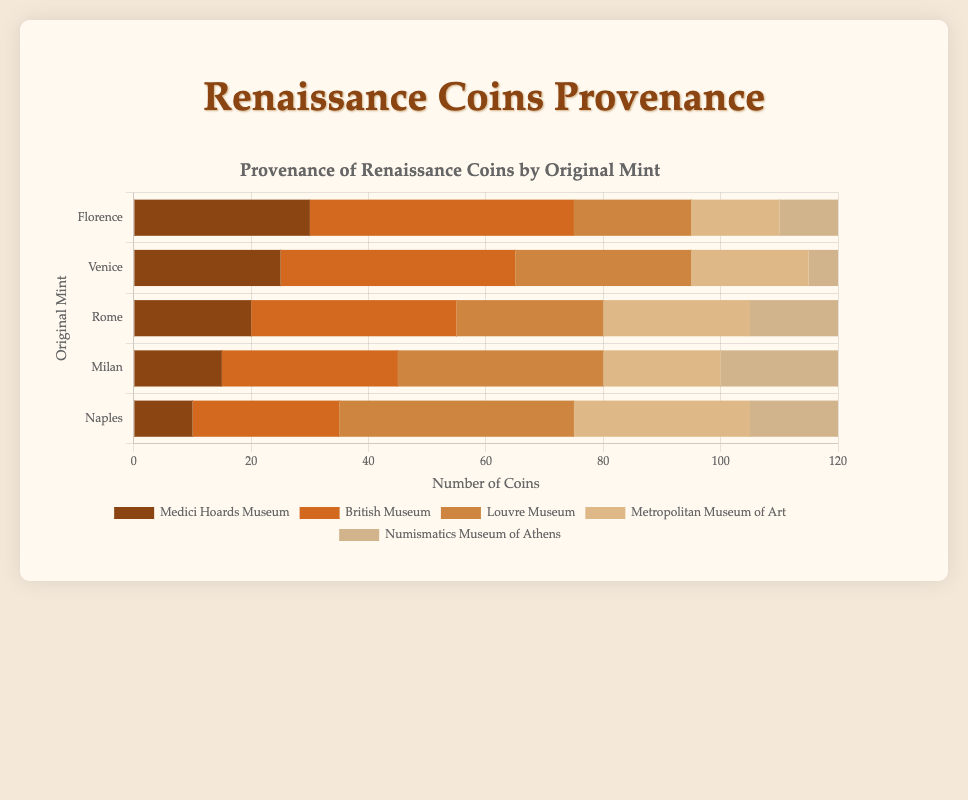What is the total number of Renaissance coins originally minted in Florence currently in the British Museum? The figure indicates a horizontal stacked bar chart, with the British Museum's portion shaded in a specific color for Florence. By observing the chart, you can see that the value is explicitly labeled next to the corresponding bar. The value is 45.
Answer: 45 Which museum has the largest collection of Renaissance coins originally minted in Milan? Identify the color-coded segments in the bar for Milan, and compare the lengths or values of each segment. The Louvre Museum has the longest segment for Milan at 35 coins.
Answer: Louvre Museum What is the combined number of Renaissance coins originally minted in Venice currently in the Medici Hoards Museum and the Louvre Museum? For Venice, sum the values for the Medici Hoards Museum (25) and the Louvre Museum (30) segments. The sum is \(25 + 30 = 55\).
Answer: 55 How does the number of Renaissance coins originally minted in Naples and currently in the Numismatics Museum of Athens compare with those in the Metropolitan Museum of Art? Find the lengths of the relevant segments in the Naples bar. Numismatics Museum of Athens is 15, and the Metropolitan Museum of Art is 30. Since \(15 < 30\), the Numismatics Museum of Athens has fewer Naples-minted coins than the Metropolitan Museum of Art.
Answer: Metropolitan Museum of Art Which original mint has the smallest collection of coins in the Numismatics Museum of Athens? Examine the Numismatics Museum of Athens segments across all mints. Venice has the smallest segment with a value of 5.
Answer: Venice What is the average number of Renaissance coins per museum originally minted in Rome? Add the number of coins for each museum for the Rome bar: Medici Hoards Museum (20), British Museum (35), Louvre Museum (25), Metropolitan Museum of Art (25), and Numismatics Museum of Athens (15). The sum is \(20 + 35 + 25 + 25 + 15 = 120\). The average is \(120 / 5 = 24\).
Answer: 24 Compare the length of the British Museum segments for Florence and Milan. Which is longer? Visually compare the lengths of the British Museum segments for both Florence and Milan. Florence has a longer segment at 45 coins compared to 30 for Milan.
Answer: Florence What is the total number of Renaissance coins from all original mints currently in the Medici Hoards Museum? Sum the Medici Hoards Museum values for all mints: Florence (30), Venice (25), Rome (20), Milan (15), and Naples (10). The sum is \(30 + 25 + 20 + 15 + 10 = 100\).
Answer: 100 How many more Renaissance coins originally minted in Florence are in the British Museum compared to those in the Louvre Museum? Find the number of coins for Florence in the British Museum (45) and the Louvre Museum (20). Subtract the latter from the former: \(45 - 20 = 25\).
Answer: 25 